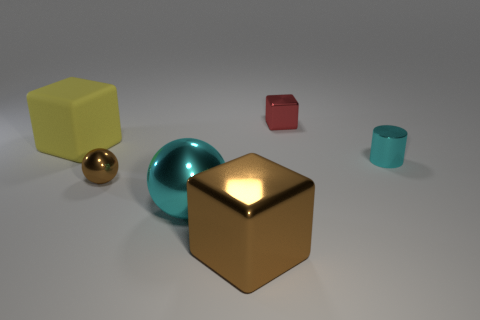Add 4 big red shiny things. How many objects exist? 10 Subtract all spheres. How many objects are left? 4 Subtract 0 purple cylinders. How many objects are left? 6 Subtract all big metal blocks. Subtract all brown cubes. How many objects are left? 4 Add 5 large cyan metal things. How many large cyan metal things are left? 6 Add 6 small cyan shiny objects. How many small cyan shiny objects exist? 7 